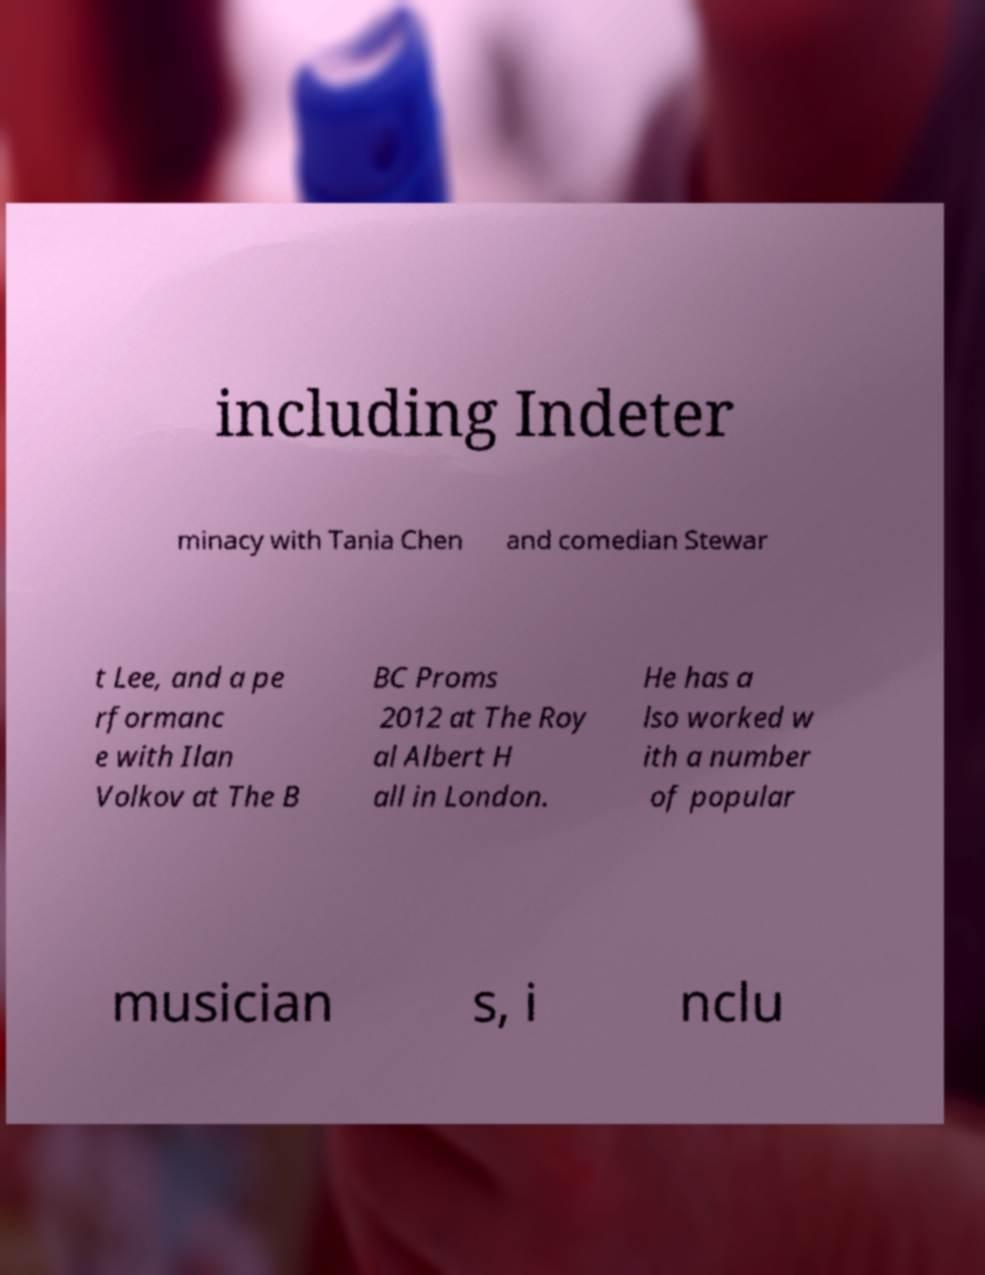Can you accurately transcribe the text from the provided image for me? including Indeter minacy with Tania Chen and comedian Stewar t Lee, and a pe rformanc e with Ilan Volkov at The B BC Proms 2012 at The Roy al Albert H all in London. He has a lso worked w ith a number of popular musician s, i nclu 